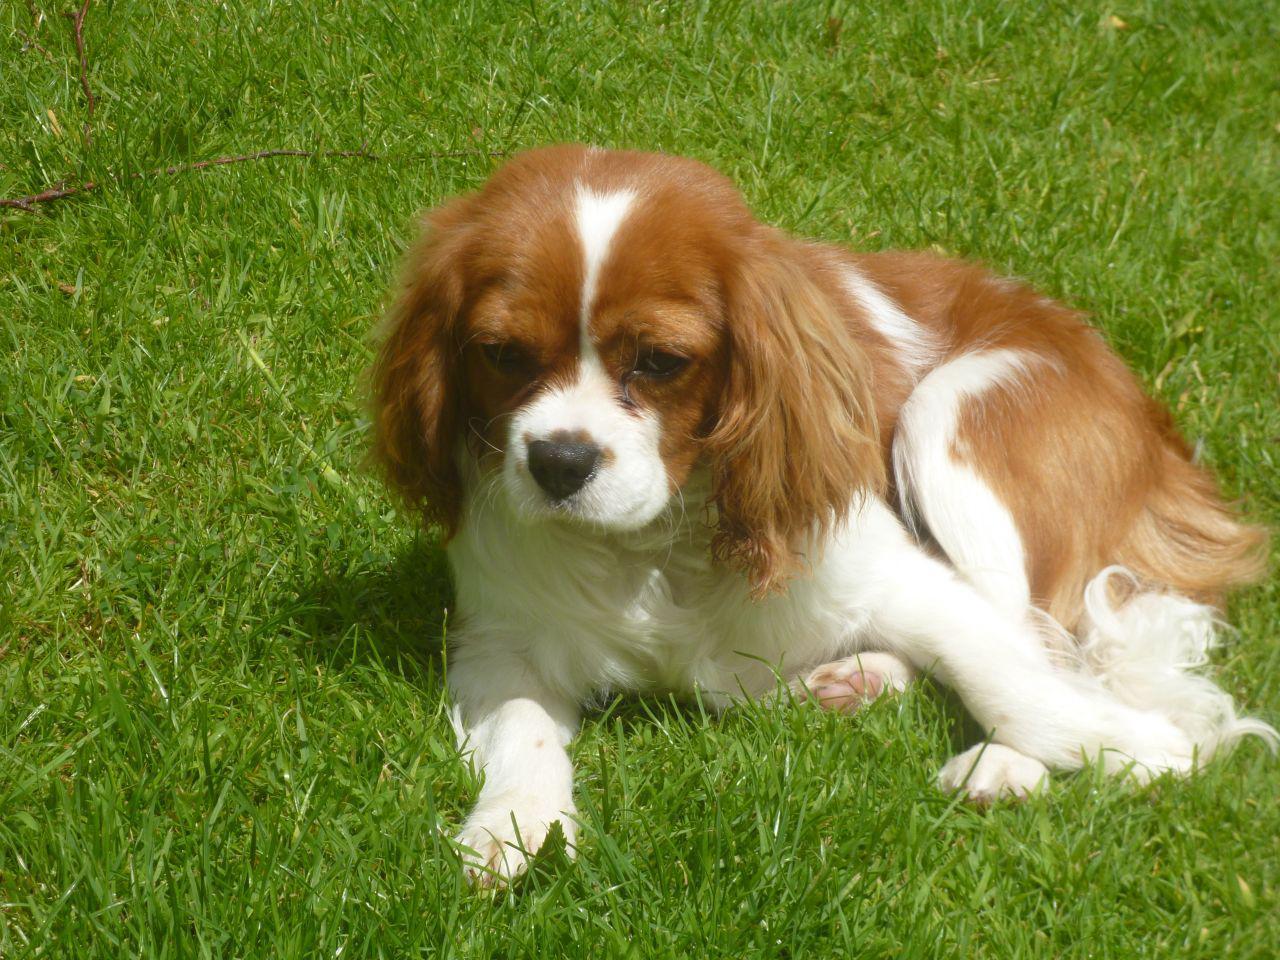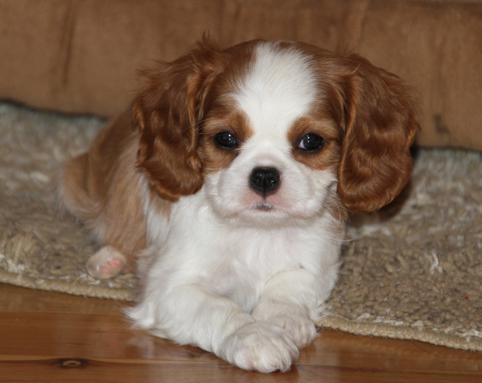The first image is the image on the left, the second image is the image on the right. Given the left and right images, does the statement "An image shows one non-standing dog posed in the grass." hold true? Answer yes or no. Yes. The first image is the image on the left, the second image is the image on the right. Assess this claim about the two images: "Each image has one dog.". Correct or not? Answer yes or no. Yes. The first image is the image on the left, the second image is the image on the right. Analyze the images presented: Is the assertion "There is a body part of a human visible in one of the images." valid? Answer yes or no. No. 